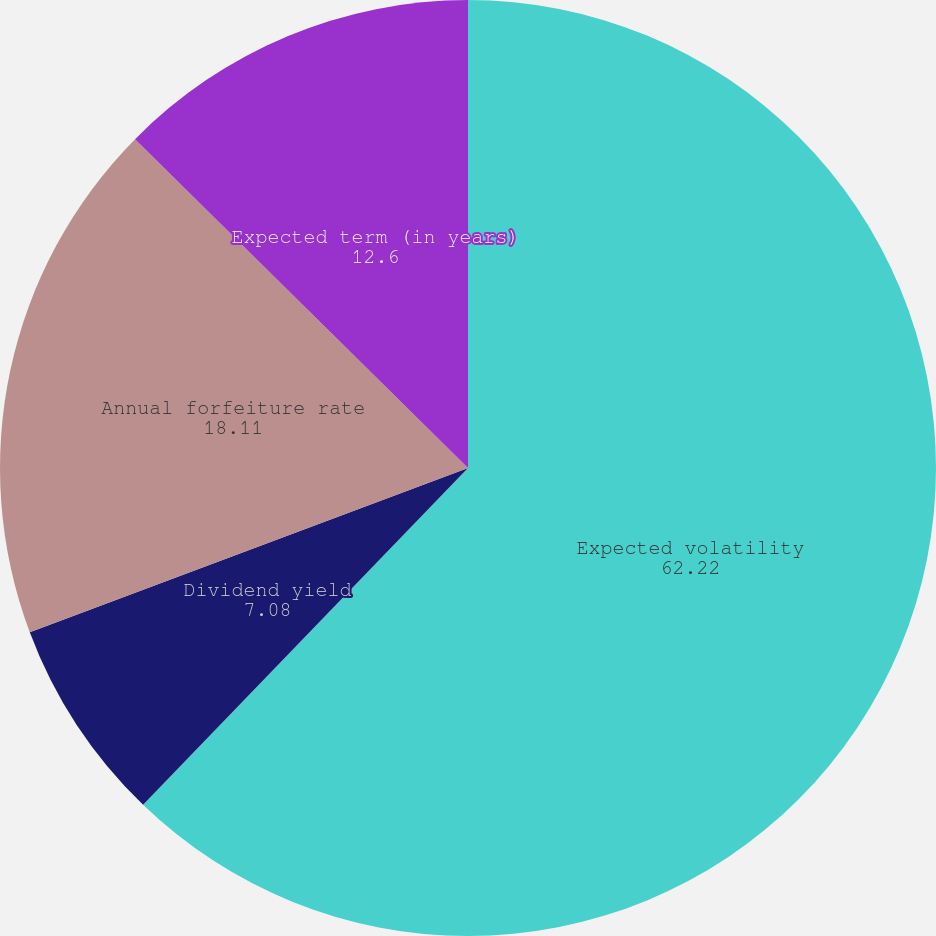Convert chart to OTSL. <chart><loc_0><loc_0><loc_500><loc_500><pie_chart><fcel>Expected volatility<fcel>Dividend yield<fcel>Annual forfeiture rate<fcel>Expected term (in years)<nl><fcel>62.22%<fcel>7.08%<fcel>18.11%<fcel>12.6%<nl></chart> 